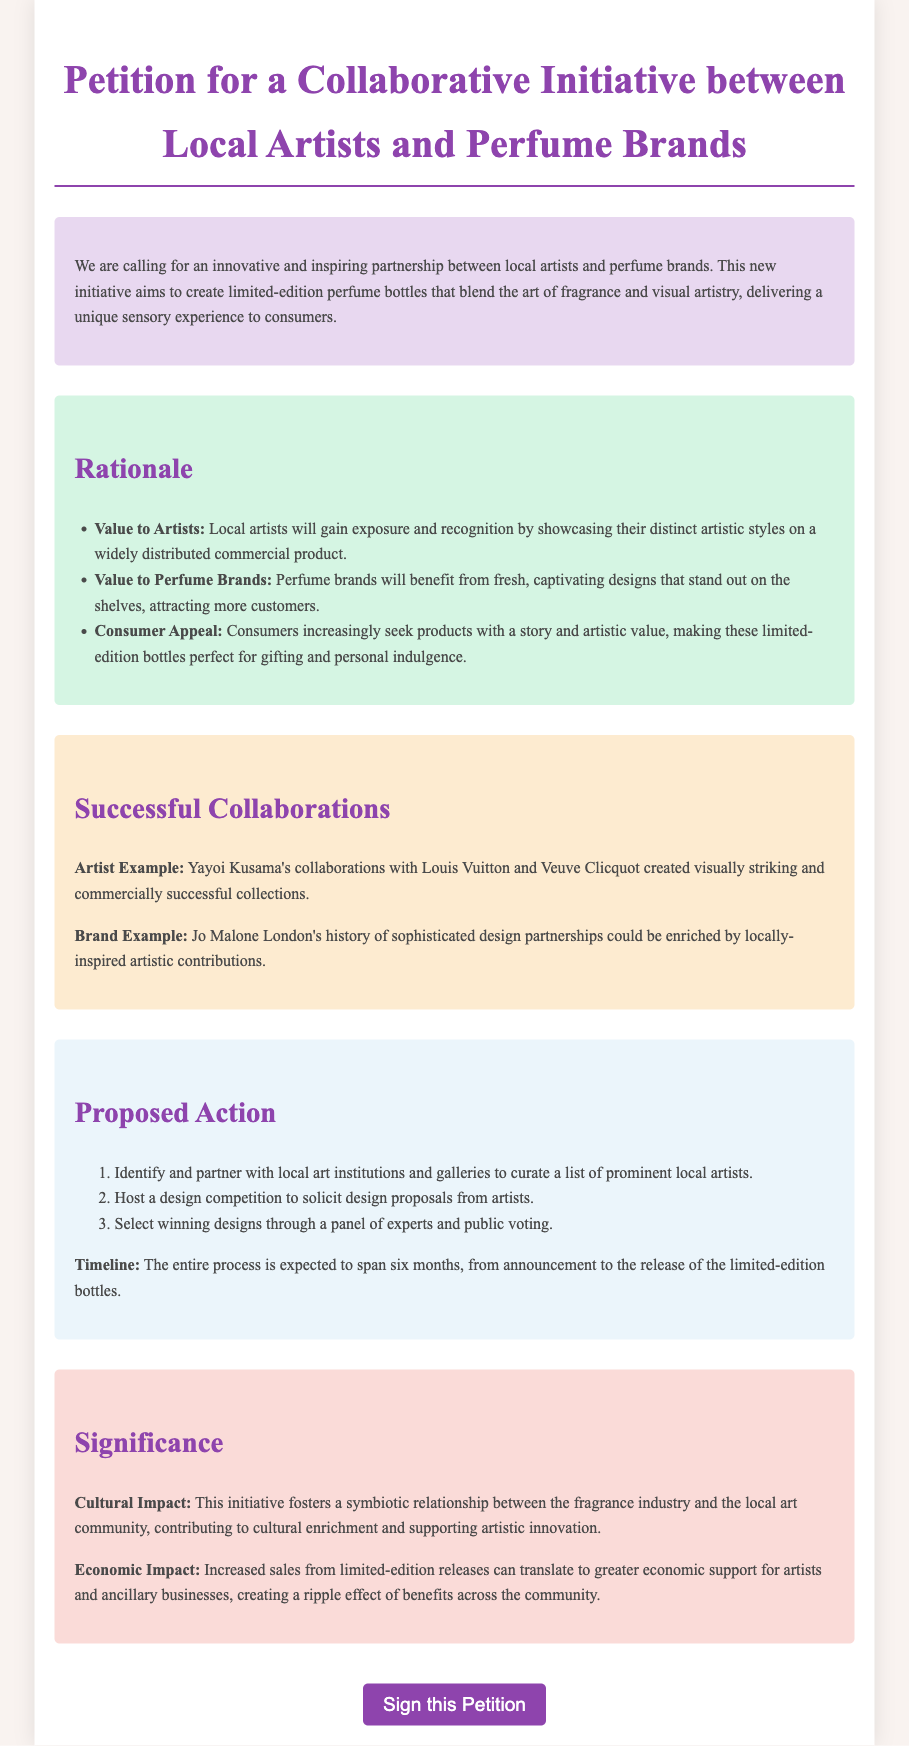What is the title of the petition? The title is stated at the top of the document, which is "Petition for a Collaborative Initiative between Local Artists and Perfume Brands".
Answer: Petition for a Collaborative Initiative between Local Artists and Perfume Brands What are the three values to artists mentioned? The document lists three values to artists, which are exposure, recognition, and showcasing their distinct artistic styles.
Answer: Exposure, recognition, distinct artistic styles How long is the expected timeline for the entire process? The document specifically mentions the timeline for the whole initiative process, which spans six months.
Answer: Six months Who is an example artist mentioned in the document? The document provides a notable artist example in the Successful Collaborations section, specifically Yayoi Kusama.
Answer: Yayoi Kusama What type of competition will be hosted to solicit design proposals? The document states that a design competition will be hosted for the purpose of soliciting proposals from artists.
Answer: Design competition What is one economic impact mentioned in the significance section? The document highlights that increased sales from limited-edition releases can lead to greater economic support for artists.
Answer: Greater economic support for artists How many steps are proposed in the action section? The document outlines a sequence of actions designed to achieve the petition's goals, specifically stating there are three steps in the proposed action.
Answer: Three steps What is the focus of the proposed collaboration? The primary emphasis of the initiative is to create limited-edition perfume bottles with unique artistic designs that blend fragrance and visual artistry.
Answer: Unique artistic designs 